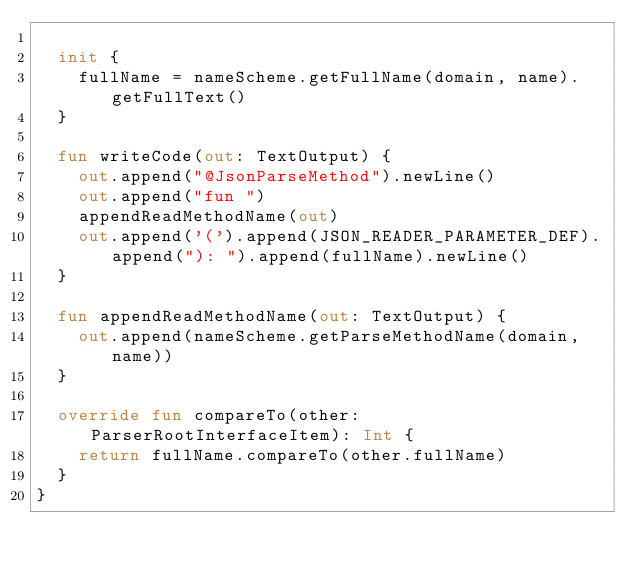Convert code to text. <code><loc_0><loc_0><loc_500><loc_500><_Kotlin_>
  init {
    fullName = nameScheme.getFullName(domain, name).getFullText()
  }

  fun writeCode(out: TextOutput) {
    out.append("@JsonParseMethod").newLine()
    out.append("fun ")
    appendReadMethodName(out)
    out.append('(').append(JSON_READER_PARAMETER_DEF).append("): ").append(fullName).newLine()
  }

  fun appendReadMethodName(out: TextOutput) {
    out.append(nameScheme.getParseMethodName(domain, name))
  }

  override fun compareTo(other: ParserRootInterfaceItem): Int {
    return fullName.compareTo(other.fullName)
  }
}
</code> 